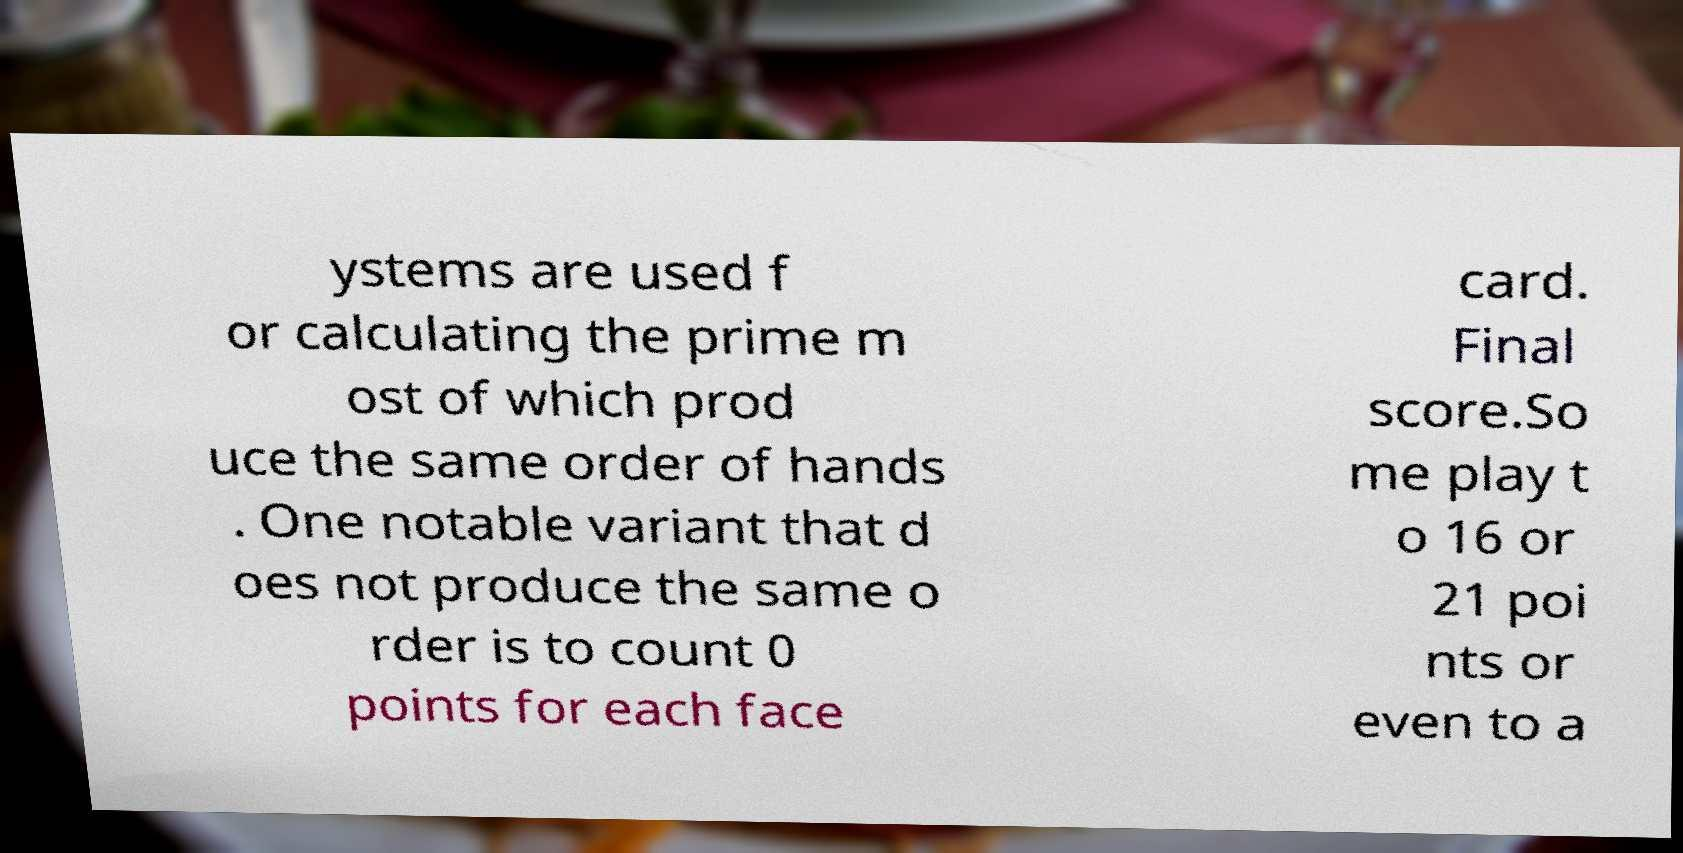Can you read and provide the text displayed in the image?This photo seems to have some interesting text. Can you extract and type it out for me? ystems are used f or calculating the prime m ost of which prod uce the same order of hands . One notable variant that d oes not produce the same o rder is to count 0 points for each face card. Final score.So me play t o 16 or 21 poi nts or even to a 